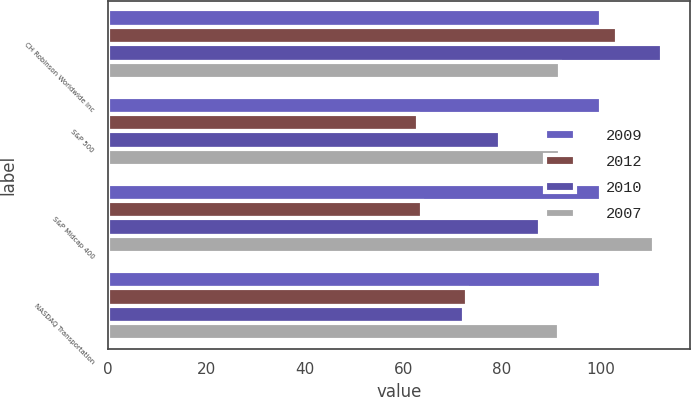Convert chart. <chart><loc_0><loc_0><loc_500><loc_500><stacked_bar_chart><ecel><fcel>CH Robinson Worldwide Inc<fcel>S&P 500<fcel>S&P Midcap 400<fcel>NASDAQ Transportation<nl><fcel>2009<fcel>100<fcel>100<fcel>100<fcel>100<nl><fcel>2012<fcel>103.4<fcel>63<fcel>63.77<fcel>72.93<nl><fcel>2010<fcel>112.48<fcel>79.67<fcel>87.61<fcel>72.29<nl><fcel>2007<fcel>91.67<fcel>91.67<fcel>110.94<fcel>91.64<nl></chart> 